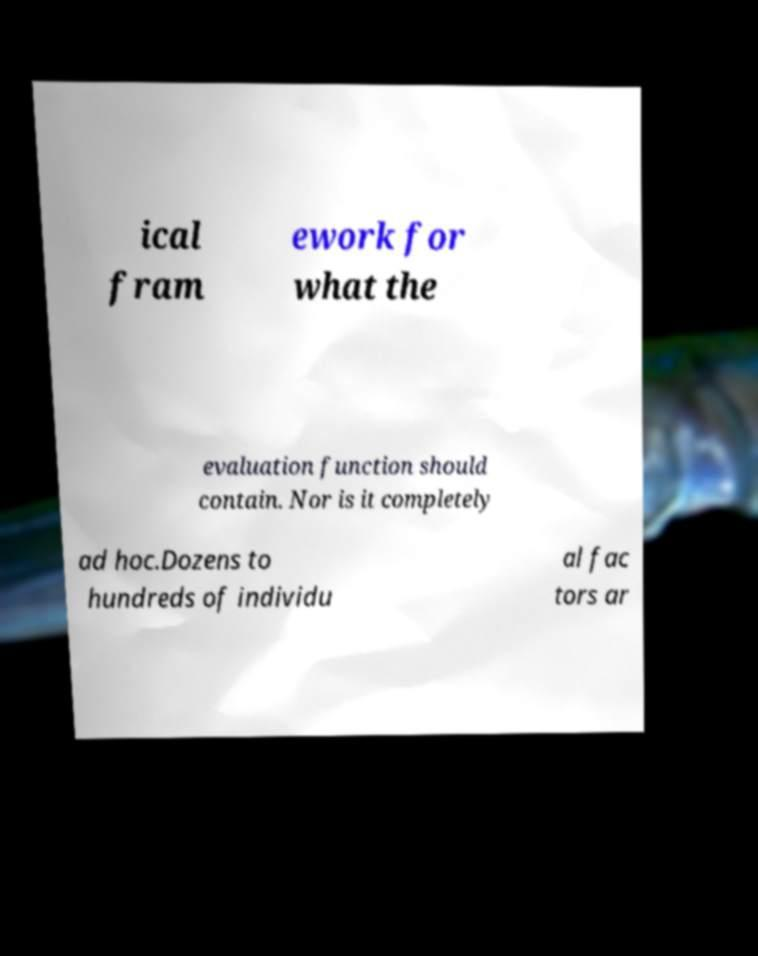For documentation purposes, I need the text within this image transcribed. Could you provide that? ical fram ework for what the evaluation function should contain. Nor is it completely ad hoc.Dozens to hundreds of individu al fac tors ar 